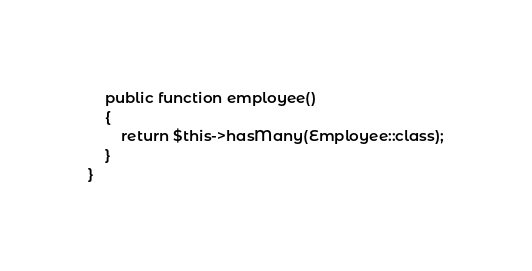Convert code to text. <code><loc_0><loc_0><loc_500><loc_500><_PHP_>
    public function employee()
    {
        return $this->hasMany(Employee::class);
    }
}
</code> 